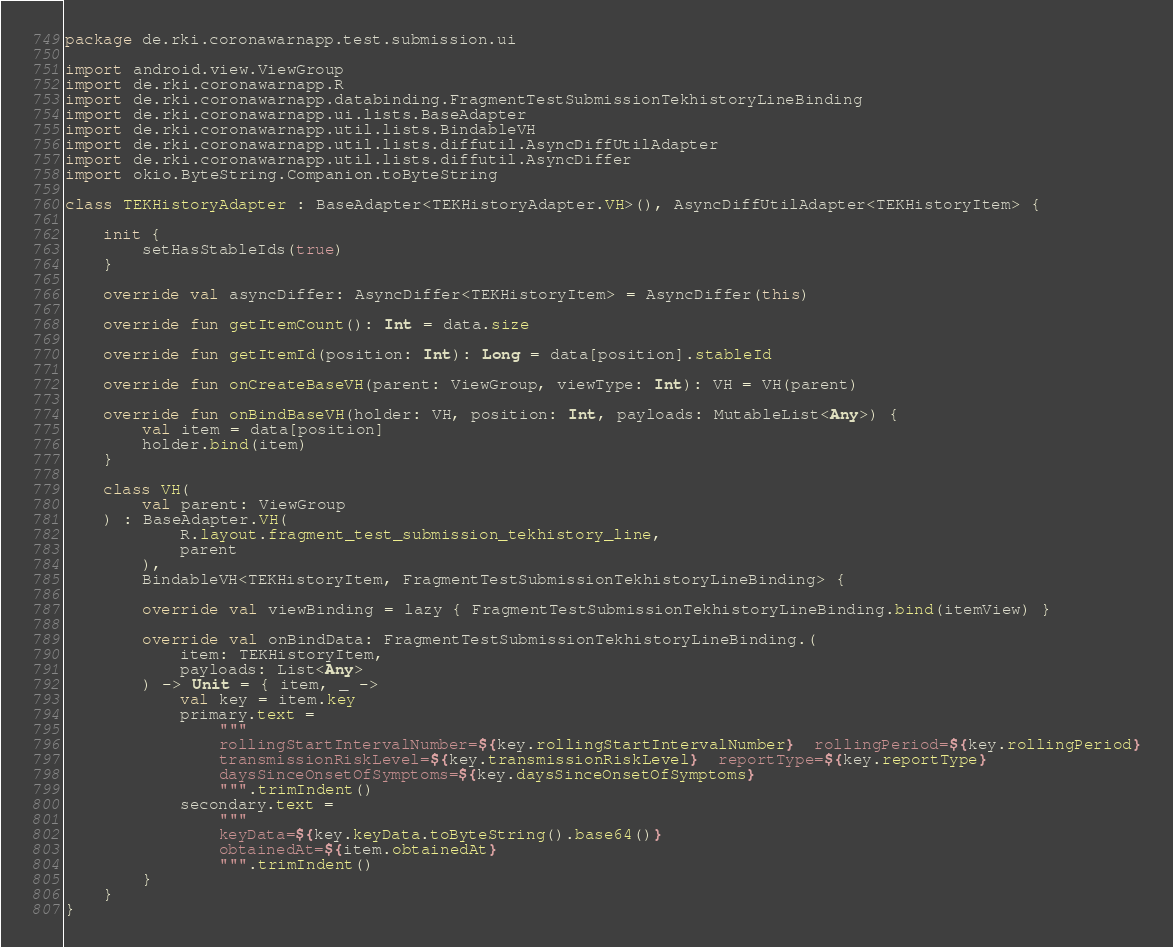Convert code to text. <code><loc_0><loc_0><loc_500><loc_500><_Kotlin_>package de.rki.coronawarnapp.test.submission.ui

import android.view.ViewGroup
import de.rki.coronawarnapp.R
import de.rki.coronawarnapp.databinding.FragmentTestSubmissionTekhistoryLineBinding
import de.rki.coronawarnapp.ui.lists.BaseAdapter
import de.rki.coronawarnapp.util.lists.BindableVH
import de.rki.coronawarnapp.util.lists.diffutil.AsyncDiffUtilAdapter
import de.rki.coronawarnapp.util.lists.diffutil.AsyncDiffer
import okio.ByteString.Companion.toByteString

class TEKHistoryAdapter : BaseAdapter<TEKHistoryAdapter.VH>(), AsyncDiffUtilAdapter<TEKHistoryItem> {

    init {
        setHasStableIds(true)
    }

    override val asyncDiffer: AsyncDiffer<TEKHistoryItem> = AsyncDiffer(this)

    override fun getItemCount(): Int = data.size

    override fun getItemId(position: Int): Long = data[position].stableId

    override fun onCreateBaseVH(parent: ViewGroup, viewType: Int): VH = VH(parent)

    override fun onBindBaseVH(holder: VH, position: Int, payloads: MutableList<Any>) {
        val item = data[position]
        holder.bind(item)
    }

    class VH(
        val parent: ViewGroup
    ) : BaseAdapter.VH(
            R.layout.fragment_test_submission_tekhistory_line,
            parent
        ),
        BindableVH<TEKHistoryItem, FragmentTestSubmissionTekhistoryLineBinding> {

        override val viewBinding = lazy { FragmentTestSubmissionTekhistoryLineBinding.bind(itemView) }

        override val onBindData: FragmentTestSubmissionTekhistoryLineBinding.(
            item: TEKHistoryItem,
            payloads: List<Any>
        ) -> Unit = { item, _ ->
            val key = item.key
            primary.text =
                """
                rollingStartIntervalNumber=${key.rollingStartIntervalNumber}  rollingPeriod=${key.rollingPeriod}
                transmissionRiskLevel=${key.transmissionRiskLevel}  reportType=${key.reportType}
                daysSinceOnsetOfSymptoms=${key.daysSinceOnsetOfSymptoms}
                """.trimIndent()
            secondary.text =
                """
                keyData=${key.keyData.toByteString().base64()}
                obtainedAt=${item.obtainedAt}
                """.trimIndent()
        }
    }
}
</code> 